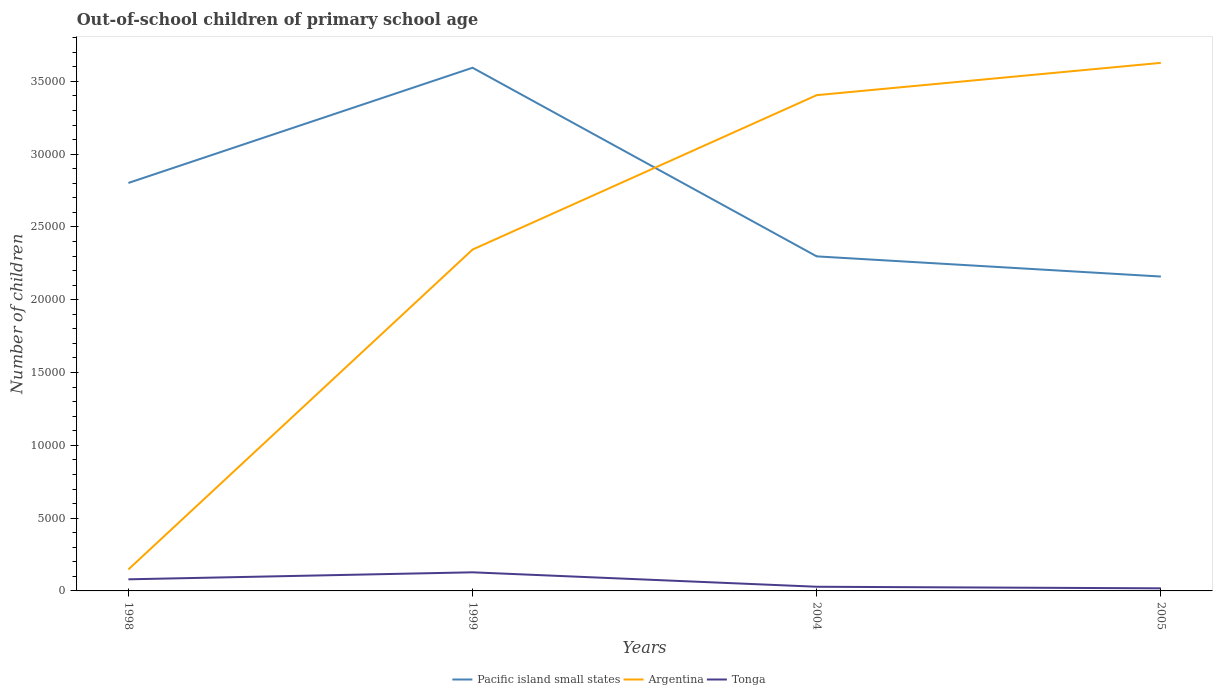Is the number of lines equal to the number of legend labels?
Offer a very short reply. Yes. Across all years, what is the maximum number of out-of-school children in Tonga?
Ensure brevity in your answer.  178. What is the total number of out-of-school children in Pacific island small states in the graph?
Make the answer very short. 1.43e+04. What is the difference between the highest and the second highest number of out-of-school children in Tonga?
Ensure brevity in your answer.  1100. Does the graph contain grids?
Provide a succinct answer. No. How are the legend labels stacked?
Make the answer very short. Horizontal. What is the title of the graph?
Offer a terse response. Out-of-school children of primary school age. Does "Eritrea" appear as one of the legend labels in the graph?
Your answer should be very brief. No. What is the label or title of the Y-axis?
Offer a very short reply. Number of children. What is the Number of children of Pacific island small states in 1998?
Keep it short and to the point. 2.80e+04. What is the Number of children in Argentina in 1998?
Provide a succinct answer. 1475. What is the Number of children in Tonga in 1998?
Your response must be concise. 797. What is the Number of children of Pacific island small states in 1999?
Your answer should be very brief. 3.59e+04. What is the Number of children in Argentina in 1999?
Make the answer very short. 2.34e+04. What is the Number of children in Tonga in 1999?
Your answer should be compact. 1278. What is the Number of children of Pacific island small states in 2004?
Your answer should be very brief. 2.30e+04. What is the Number of children in Argentina in 2004?
Make the answer very short. 3.41e+04. What is the Number of children in Tonga in 2004?
Make the answer very short. 287. What is the Number of children of Pacific island small states in 2005?
Your answer should be compact. 2.16e+04. What is the Number of children of Argentina in 2005?
Provide a succinct answer. 3.63e+04. What is the Number of children of Tonga in 2005?
Offer a terse response. 178. Across all years, what is the maximum Number of children of Pacific island small states?
Provide a succinct answer. 3.59e+04. Across all years, what is the maximum Number of children in Argentina?
Ensure brevity in your answer.  3.63e+04. Across all years, what is the maximum Number of children of Tonga?
Keep it short and to the point. 1278. Across all years, what is the minimum Number of children in Pacific island small states?
Give a very brief answer. 2.16e+04. Across all years, what is the minimum Number of children in Argentina?
Ensure brevity in your answer.  1475. Across all years, what is the minimum Number of children of Tonga?
Make the answer very short. 178. What is the total Number of children in Pacific island small states in the graph?
Offer a terse response. 1.09e+05. What is the total Number of children of Argentina in the graph?
Your answer should be very brief. 9.52e+04. What is the total Number of children in Tonga in the graph?
Provide a succinct answer. 2540. What is the difference between the Number of children in Pacific island small states in 1998 and that in 1999?
Keep it short and to the point. -7912. What is the difference between the Number of children in Argentina in 1998 and that in 1999?
Provide a short and direct response. -2.20e+04. What is the difference between the Number of children in Tonga in 1998 and that in 1999?
Keep it short and to the point. -481. What is the difference between the Number of children in Pacific island small states in 1998 and that in 2004?
Provide a short and direct response. 5043. What is the difference between the Number of children of Argentina in 1998 and that in 2004?
Give a very brief answer. -3.26e+04. What is the difference between the Number of children of Tonga in 1998 and that in 2004?
Your answer should be compact. 510. What is the difference between the Number of children of Pacific island small states in 1998 and that in 2005?
Give a very brief answer. 6428. What is the difference between the Number of children in Argentina in 1998 and that in 2005?
Your answer should be compact. -3.48e+04. What is the difference between the Number of children of Tonga in 1998 and that in 2005?
Make the answer very short. 619. What is the difference between the Number of children of Pacific island small states in 1999 and that in 2004?
Keep it short and to the point. 1.30e+04. What is the difference between the Number of children in Argentina in 1999 and that in 2004?
Your answer should be very brief. -1.06e+04. What is the difference between the Number of children of Tonga in 1999 and that in 2004?
Your answer should be very brief. 991. What is the difference between the Number of children in Pacific island small states in 1999 and that in 2005?
Provide a short and direct response. 1.43e+04. What is the difference between the Number of children of Argentina in 1999 and that in 2005?
Your answer should be compact. -1.28e+04. What is the difference between the Number of children in Tonga in 1999 and that in 2005?
Keep it short and to the point. 1100. What is the difference between the Number of children in Pacific island small states in 2004 and that in 2005?
Make the answer very short. 1385. What is the difference between the Number of children in Argentina in 2004 and that in 2005?
Make the answer very short. -2219. What is the difference between the Number of children of Tonga in 2004 and that in 2005?
Offer a terse response. 109. What is the difference between the Number of children in Pacific island small states in 1998 and the Number of children in Argentina in 1999?
Ensure brevity in your answer.  4575. What is the difference between the Number of children of Pacific island small states in 1998 and the Number of children of Tonga in 1999?
Your answer should be very brief. 2.67e+04. What is the difference between the Number of children in Argentina in 1998 and the Number of children in Tonga in 1999?
Ensure brevity in your answer.  197. What is the difference between the Number of children in Pacific island small states in 1998 and the Number of children in Argentina in 2004?
Provide a short and direct response. -6030. What is the difference between the Number of children in Pacific island small states in 1998 and the Number of children in Tonga in 2004?
Offer a terse response. 2.77e+04. What is the difference between the Number of children in Argentina in 1998 and the Number of children in Tonga in 2004?
Provide a short and direct response. 1188. What is the difference between the Number of children in Pacific island small states in 1998 and the Number of children in Argentina in 2005?
Give a very brief answer. -8249. What is the difference between the Number of children in Pacific island small states in 1998 and the Number of children in Tonga in 2005?
Ensure brevity in your answer.  2.78e+04. What is the difference between the Number of children in Argentina in 1998 and the Number of children in Tonga in 2005?
Make the answer very short. 1297. What is the difference between the Number of children in Pacific island small states in 1999 and the Number of children in Argentina in 2004?
Give a very brief answer. 1882. What is the difference between the Number of children in Pacific island small states in 1999 and the Number of children in Tonga in 2004?
Your answer should be very brief. 3.56e+04. What is the difference between the Number of children in Argentina in 1999 and the Number of children in Tonga in 2004?
Provide a short and direct response. 2.32e+04. What is the difference between the Number of children of Pacific island small states in 1999 and the Number of children of Argentina in 2005?
Provide a succinct answer. -337. What is the difference between the Number of children in Pacific island small states in 1999 and the Number of children in Tonga in 2005?
Keep it short and to the point. 3.58e+04. What is the difference between the Number of children in Argentina in 1999 and the Number of children in Tonga in 2005?
Ensure brevity in your answer.  2.33e+04. What is the difference between the Number of children of Pacific island small states in 2004 and the Number of children of Argentina in 2005?
Keep it short and to the point. -1.33e+04. What is the difference between the Number of children of Pacific island small states in 2004 and the Number of children of Tonga in 2005?
Ensure brevity in your answer.  2.28e+04. What is the difference between the Number of children of Argentina in 2004 and the Number of children of Tonga in 2005?
Provide a succinct answer. 3.39e+04. What is the average Number of children of Pacific island small states per year?
Keep it short and to the point. 2.71e+04. What is the average Number of children of Argentina per year?
Keep it short and to the point. 2.38e+04. What is the average Number of children in Tonga per year?
Your answer should be very brief. 635. In the year 1998, what is the difference between the Number of children in Pacific island small states and Number of children in Argentina?
Your response must be concise. 2.65e+04. In the year 1998, what is the difference between the Number of children in Pacific island small states and Number of children in Tonga?
Provide a succinct answer. 2.72e+04. In the year 1998, what is the difference between the Number of children of Argentina and Number of children of Tonga?
Give a very brief answer. 678. In the year 1999, what is the difference between the Number of children of Pacific island small states and Number of children of Argentina?
Give a very brief answer. 1.25e+04. In the year 1999, what is the difference between the Number of children of Pacific island small states and Number of children of Tonga?
Your response must be concise. 3.47e+04. In the year 1999, what is the difference between the Number of children of Argentina and Number of children of Tonga?
Your answer should be very brief. 2.22e+04. In the year 2004, what is the difference between the Number of children of Pacific island small states and Number of children of Argentina?
Give a very brief answer. -1.11e+04. In the year 2004, what is the difference between the Number of children of Pacific island small states and Number of children of Tonga?
Your answer should be compact. 2.27e+04. In the year 2004, what is the difference between the Number of children in Argentina and Number of children in Tonga?
Your answer should be compact. 3.38e+04. In the year 2005, what is the difference between the Number of children of Pacific island small states and Number of children of Argentina?
Keep it short and to the point. -1.47e+04. In the year 2005, what is the difference between the Number of children of Pacific island small states and Number of children of Tonga?
Give a very brief answer. 2.14e+04. In the year 2005, what is the difference between the Number of children of Argentina and Number of children of Tonga?
Offer a terse response. 3.61e+04. What is the ratio of the Number of children in Pacific island small states in 1998 to that in 1999?
Ensure brevity in your answer.  0.78. What is the ratio of the Number of children of Argentina in 1998 to that in 1999?
Keep it short and to the point. 0.06. What is the ratio of the Number of children of Tonga in 1998 to that in 1999?
Make the answer very short. 0.62. What is the ratio of the Number of children in Pacific island small states in 1998 to that in 2004?
Offer a terse response. 1.22. What is the ratio of the Number of children in Argentina in 1998 to that in 2004?
Your answer should be compact. 0.04. What is the ratio of the Number of children in Tonga in 1998 to that in 2004?
Provide a short and direct response. 2.78. What is the ratio of the Number of children of Pacific island small states in 1998 to that in 2005?
Your answer should be compact. 1.3. What is the ratio of the Number of children of Argentina in 1998 to that in 2005?
Provide a short and direct response. 0.04. What is the ratio of the Number of children of Tonga in 1998 to that in 2005?
Your answer should be very brief. 4.48. What is the ratio of the Number of children of Pacific island small states in 1999 to that in 2004?
Keep it short and to the point. 1.56. What is the ratio of the Number of children in Argentina in 1999 to that in 2004?
Keep it short and to the point. 0.69. What is the ratio of the Number of children in Tonga in 1999 to that in 2004?
Give a very brief answer. 4.45. What is the ratio of the Number of children in Pacific island small states in 1999 to that in 2005?
Your response must be concise. 1.66. What is the ratio of the Number of children in Argentina in 1999 to that in 2005?
Give a very brief answer. 0.65. What is the ratio of the Number of children of Tonga in 1999 to that in 2005?
Provide a succinct answer. 7.18. What is the ratio of the Number of children in Pacific island small states in 2004 to that in 2005?
Provide a short and direct response. 1.06. What is the ratio of the Number of children in Argentina in 2004 to that in 2005?
Your response must be concise. 0.94. What is the ratio of the Number of children of Tonga in 2004 to that in 2005?
Provide a short and direct response. 1.61. What is the difference between the highest and the second highest Number of children in Pacific island small states?
Keep it short and to the point. 7912. What is the difference between the highest and the second highest Number of children of Argentina?
Offer a very short reply. 2219. What is the difference between the highest and the second highest Number of children in Tonga?
Give a very brief answer. 481. What is the difference between the highest and the lowest Number of children of Pacific island small states?
Offer a very short reply. 1.43e+04. What is the difference between the highest and the lowest Number of children in Argentina?
Keep it short and to the point. 3.48e+04. What is the difference between the highest and the lowest Number of children in Tonga?
Keep it short and to the point. 1100. 